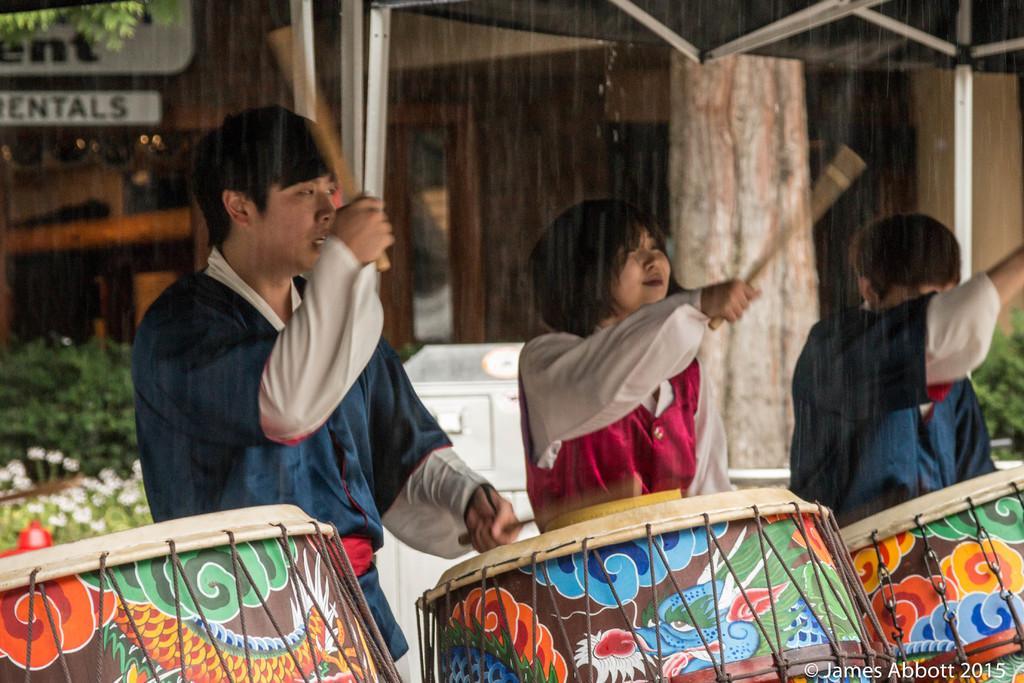Please provide a concise description of this image. In this image there are 2 man standing and beating the drums , another woman standing and beating the drums with the drum sticks , and in back ground there is plants, flowers, tree ,name board , building. 